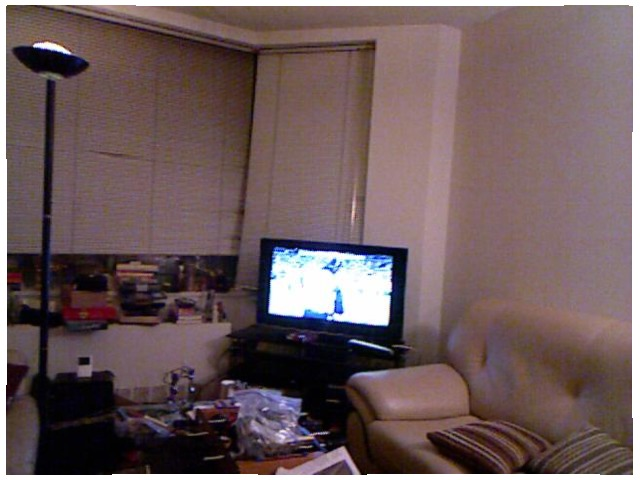<image>
Can you confirm if the pillow is in front of the wall? Yes. The pillow is positioned in front of the wall, appearing closer to the camera viewpoint. Where is the book in relation to the table? Is it on the table? No. The book is not positioned on the table. They may be near each other, but the book is not supported by or resting on top of the table. Where is the tv in relation to the couch? Is it behind the couch? No. The tv is not behind the couch. From this viewpoint, the tv appears to be positioned elsewhere in the scene. 